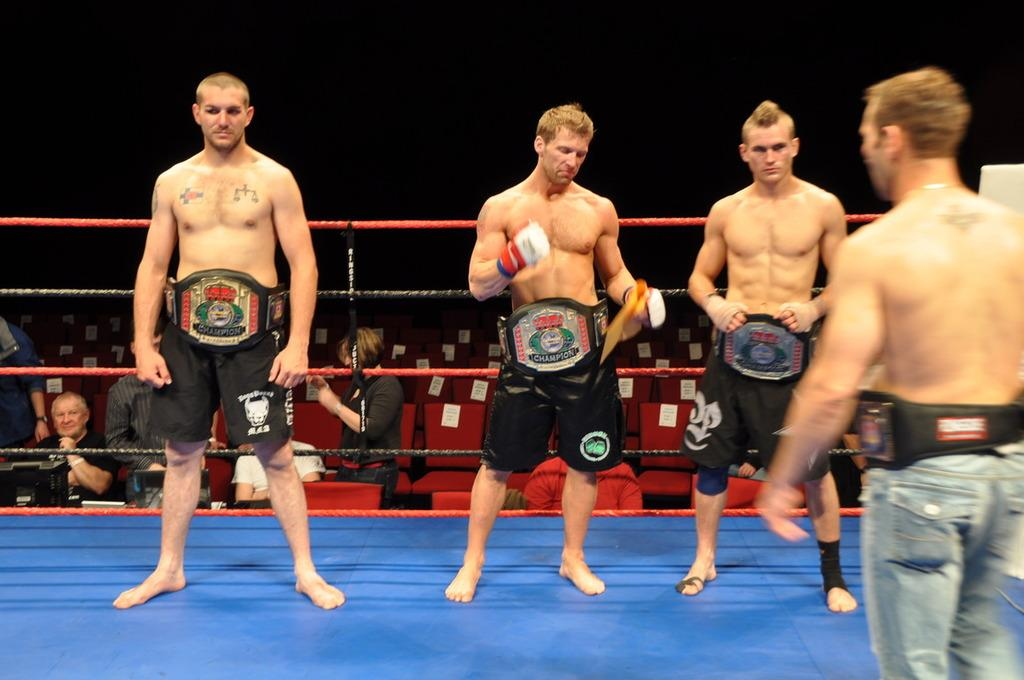What is happening on the boxing floor in the image? There are people standing on the boxing floor in the image. Can you describe the background of the image? There are people in the background of the image. What objects are present in the image that might be used for sitting? There are chairs with text papers attached to them in the image. What type of card is being used to solve a riddle in the image? There is no card or riddle present in the image. What kind of request is being made by the people in the image? There is no request being made by the people in the image. 